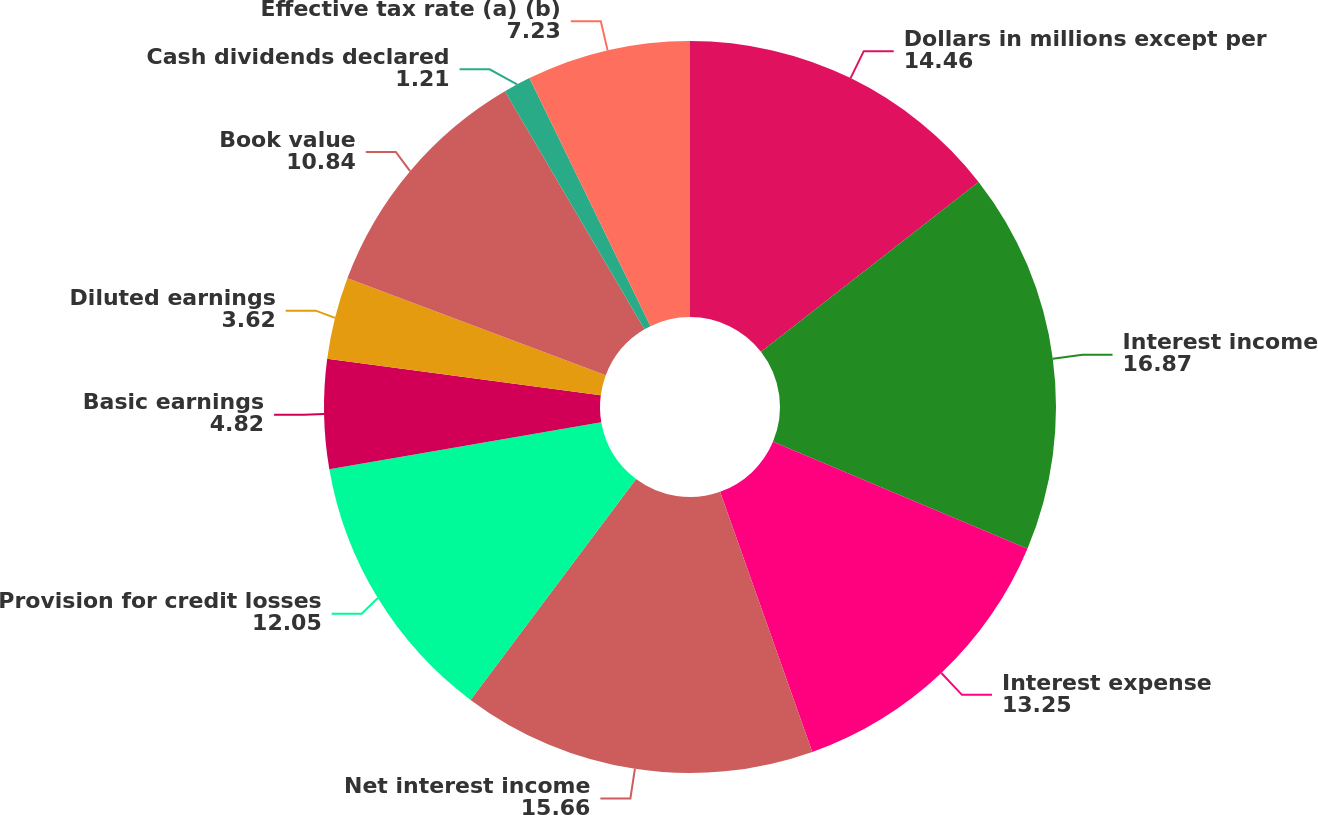Convert chart to OTSL. <chart><loc_0><loc_0><loc_500><loc_500><pie_chart><fcel>Dollars in millions except per<fcel>Interest income<fcel>Interest expense<fcel>Net interest income<fcel>Provision for credit losses<fcel>Basic earnings<fcel>Diluted earnings<fcel>Book value<fcel>Cash dividends declared<fcel>Effective tax rate (a) (b)<nl><fcel>14.46%<fcel>16.87%<fcel>13.25%<fcel>15.66%<fcel>12.05%<fcel>4.82%<fcel>3.62%<fcel>10.84%<fcel>1.21%<fcel>7.23%<nl></chart> 